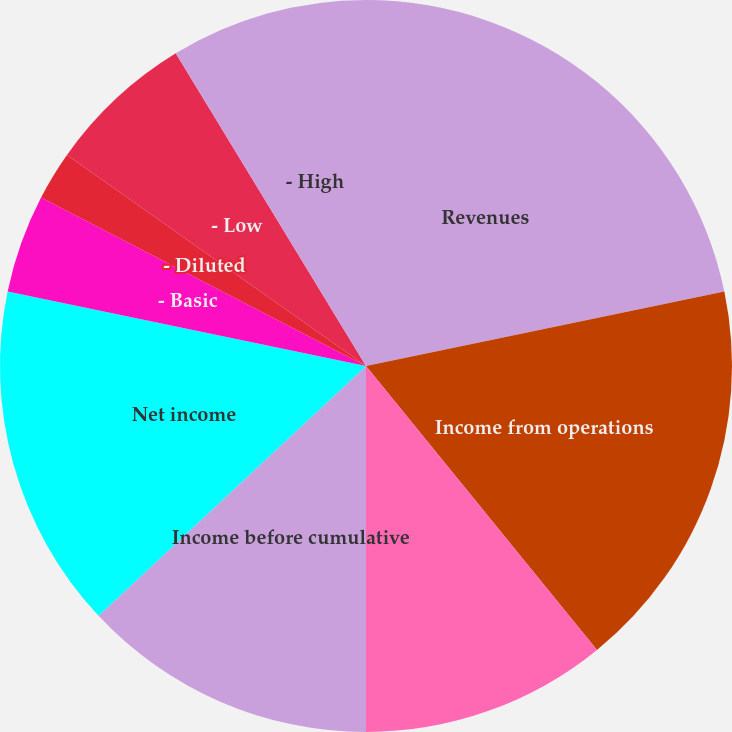<chart> <loc_0><loc_0><loc_500><loc_500><pie_chart><fcel>Revenues<fcel>Income from operations<fcel>Income from continuing<fcel>Income before cumulative<fcel>Net income<fcel>- Basic<fcel>- Diluted<fcel>Dividends paid per share<fcel>- Low<fcel>- High<nl><fcel>21.74%<fcel>17.39%<fcel>10.87%<fcel>13.04%<fcel>15.22%<fcel>4.35%<fcel>2.17%<fcel>0.0%<fcel>6.52%<fcel>8.7%<nl></chart> 